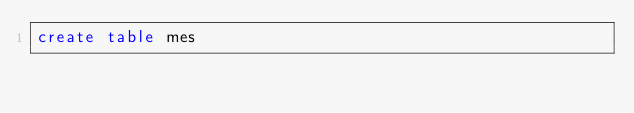<code> <loc_0><loc_0><loc_500><loc_500><_SQL_>create table mes
</code> 